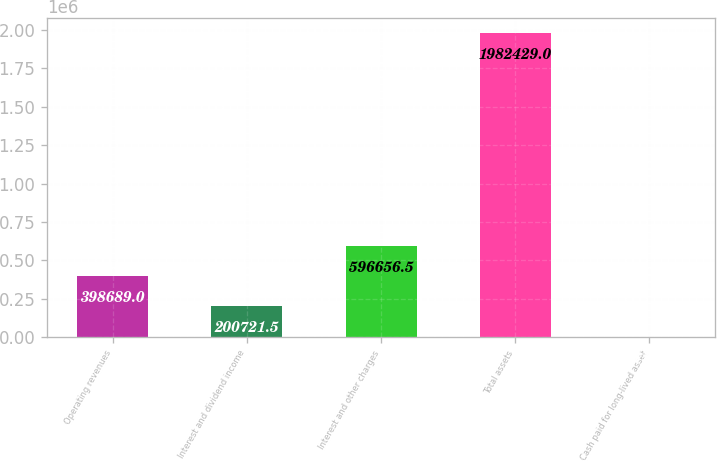Convert chart. <chart><loc_0><loc_0><loc_500><loc_500><bar_chart><fcel>Operating revenues<fcel>Interest and dividend income<fcel>Interest and other charges<fcel>Total assets<fcel>Cash paid for long-lived asset<nl><fcel>398689<fcel>200722<fcel>596656<fcel>1.98243e+06<fcel>2754<nl></chart> 